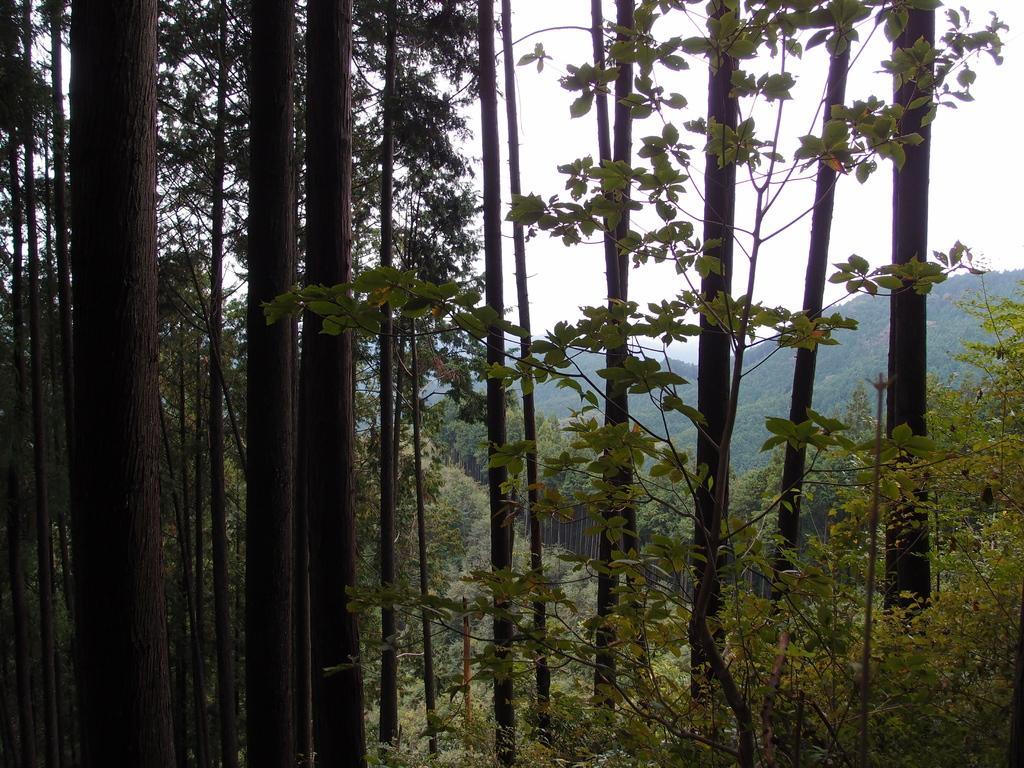Describe this image in one or two sentences. In this picture we can see trees, mountains and in the background we can see the sky. 